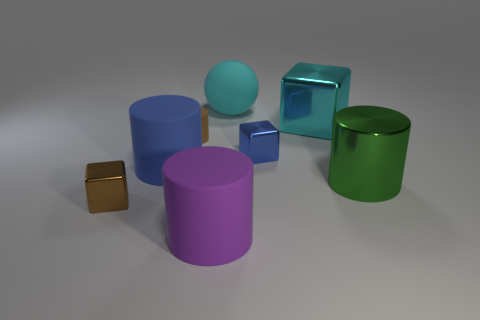Is the number of large cylinders that are behind the small cylinder the same as the number of big purple cubes?
Your response must be concise. Yes. What number of cylinders are either red metal things or brown rubber things?
Offer a very short reply. 1. What is the color of the large ball that is the same material as the purple cylinder?
Provide a succinct answer. Cyan. Is the tiny cylinder made of the same material as the cube in front of the large metal cylinder?
Offer a terse response. No. How many objects are small gray matte blocks or small shiny objects?
Provide a succinct answer. 2. There is a cube that is the same color as the rubber sphere; what is it made of?
Provide a short and direct response. Metal. Is there a yellow object of the same shape as the cyan rubber thing?
Offer a very short reply. No. What number of green things are to the left of the cyan rubber thing?
Your answer should be very brief. 0. There is a brown thing right of the blue thing on the left side of the big cyan ball; what is its material?
Your answer should be very brief. Rubber. There is a blue object that is the same size as the cyan sphere; what is its material?
Your answer should be very brief. Rubber. 